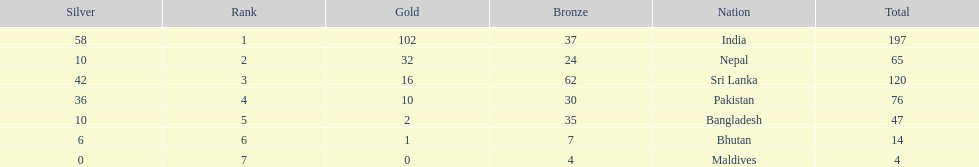Which individual has secured the most bronze medals in their career? Sri Lanka. 